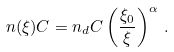<formula> <loc_0><loc_0><loc_500><loc_500>n ( \xi ) C = n _ { d } C \left ( \frac { \xi _ { 0 } } { \xi } \right ) ^ { \alpha } \, .</formula> 